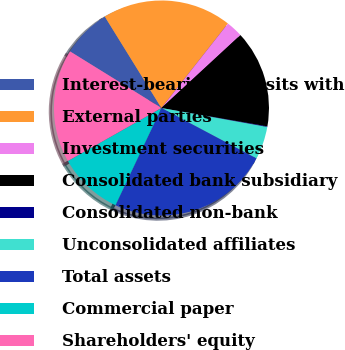Convert chart to OTSL. <chart><loc_0><loc_0><loc_500><loc_500><pie_chart><fcel>Interest-bearing deposits with<fcel>External parties<fcel>Investment securities<fcel>Consolidated bank subsidiary<fcel>Consolidated non-bank<fcel>Unconsolidated affiliates<fcel>Total assets<fcel>Commercial paper<fcel>Shareholders' equity<nl><fcel>7.35%<fcel>19.44%<fcel>2.52%<fcel>14.6%<fcel>0.1%<fcel>4.93%<fcel>24.27%<fcel>9.77%<fcel>17.02%<nl></chart> 